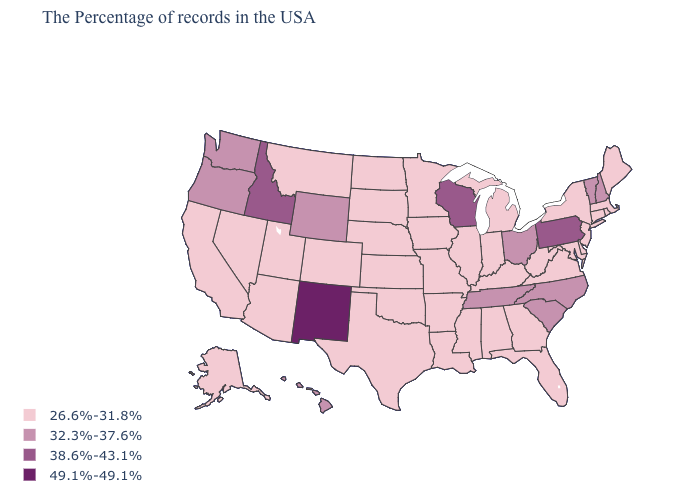Name the states that have a value in the range 26.6%-31.8%?
Short answer required. Maine, Massachusetts, Rhode Island, Connecticut, New York, New Jersey, Delaware, Maryland, Virginia, West Virginia, Florida, Georgia, Michigan, Kentucky, Indiana, Alabama, Illinois, Mississippi, Louisiana, Missouri, Arkansas, Minnesota, Iowa, Kansas, Nebraska, Oklahoma, Texas, South Dakota, North Dakota, Colorado, Utah, Montana, Arizona, Nevada, California, Alaska. Among the states that border Kentucky , which have the lowest value?
Concise answer only. Virginia, West Virginia, Indiana, Illinois, Missouri. Name the states that have a value in the range 32.3%-37.6%?
Answer briefly. New Hampshire, Vermont, North Carolina, South Carolina, Ohio, Tennessee, Wyoming, Washington, Oregon, Hawaii. What is the value of Colorado?
Keep it brief. 26.6%-31.8%. Is the legend a continuous bar?
Concise answer only. No. Name the states that have a value in the range 32.3%-37.6%?
Quick response, please. New Hampshire, Vermont, North Carolina, South Carolina, Ohio, Tennessee, Wyoming, Washington, Oregon, Hawaii. What is the value of North Dakota?
Short answer required. 26.6%-31.8%. Among the states that border Wisconsin , which have the lowest value?
Answer briefly. Michigan, Illinois, Minnesota, Iowa. Among the states that border Minnesota , does South Dakota have the lowest value?
Give a very brief answer. Yes. Name the states that have a value in the range 26.6%-31.8%?
Keep it brief. Maine, Massachusetts, Rhode Island, Connecticut, New York, New Jersey, Delaware, Maryland, Virginia, West Virginia, Florida, Georgia, Michigan, Kentucky, Indiana, Alabama, Illinois, Mississippi, Louisiana, Missouri, Arkansas, Minnesota, Iowa, Kansas, Nebraska, Oklahoma, Texas, South Dakota, North Dakota, Colorado, Utah, Montana, Arizona, Nevada, California, Alaska. What is the lowest value in the USA?
Answer briefly. 26.6%-31.8%. What is the value of Minnesota?
Concise answer only. 26.6%-31.8%. How many symbols are there in the legend?
Write a very short answer. 4. Which states have the highest value in the USA?
Write a very short answer. New Mexico. What is the lowest value in the USA?
Give a very brief answer. 26.6%-31.8%. 